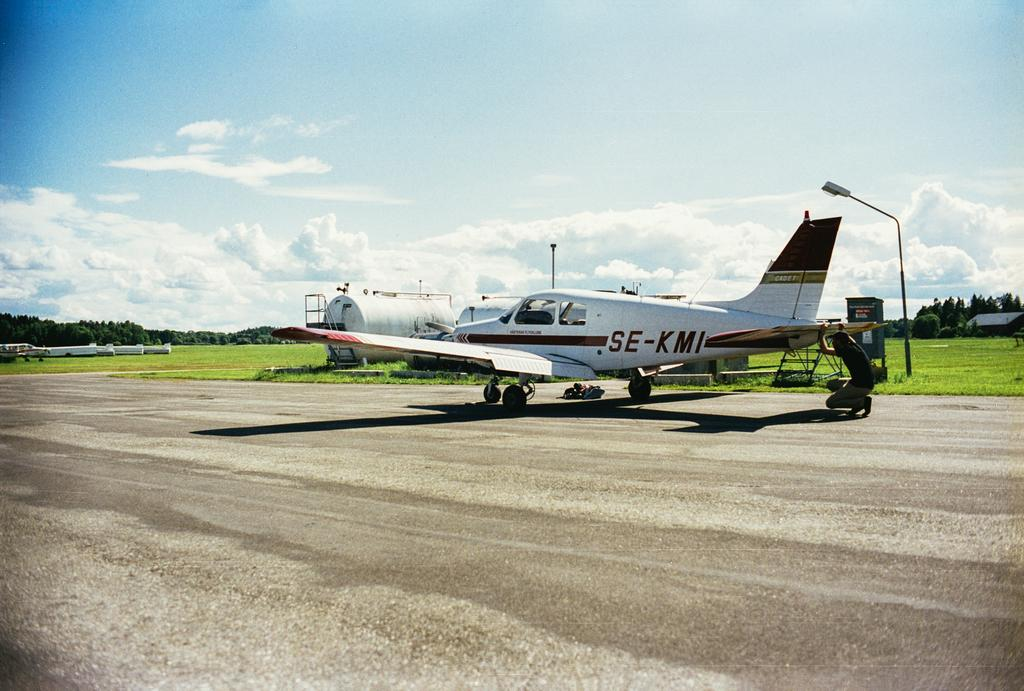<image>
Describe the image concisely. Small Charter Plane with the label on the side: SE-KMI. 